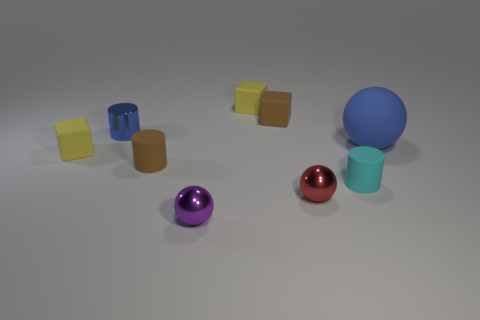What is the size of the matte ball?
Provide a short and direct response. Large. What number of brown objects have the same size as the brown cylinder?
Ensure brevity in your answer.  1. How many other tiny shiny things have the same shape as the blue metal thing?
Offer a terse response. 0. Are there the same number of small yellow objects that are left of the big ball and brown things?
Your answer should be very brief. Yes. Are there any other things that have the same size as the blue ball?
Ensure brevity in your answer.  No. What shape is the purple thing that is the same size as the brown cube?
Your response must be concise. Sphere. Are there any large blue things that have the same shape as the purple object?
Ensure brevity in your answer.  Yes. There is a yellow rubber block that is in front of the small yellow thing right of the blue metal object; are there any small yellow objects that are on the right side of it?
Provide a succinct answer. Yes. Are there more red metallic things behind the cyan cylinder than red shiny spheres that are on the left side of the brown block?
Keep it short and to the point. No. What is the material of the brown block that is the same size as the metal cylinder?
Give a very brief answer. Rubber. 